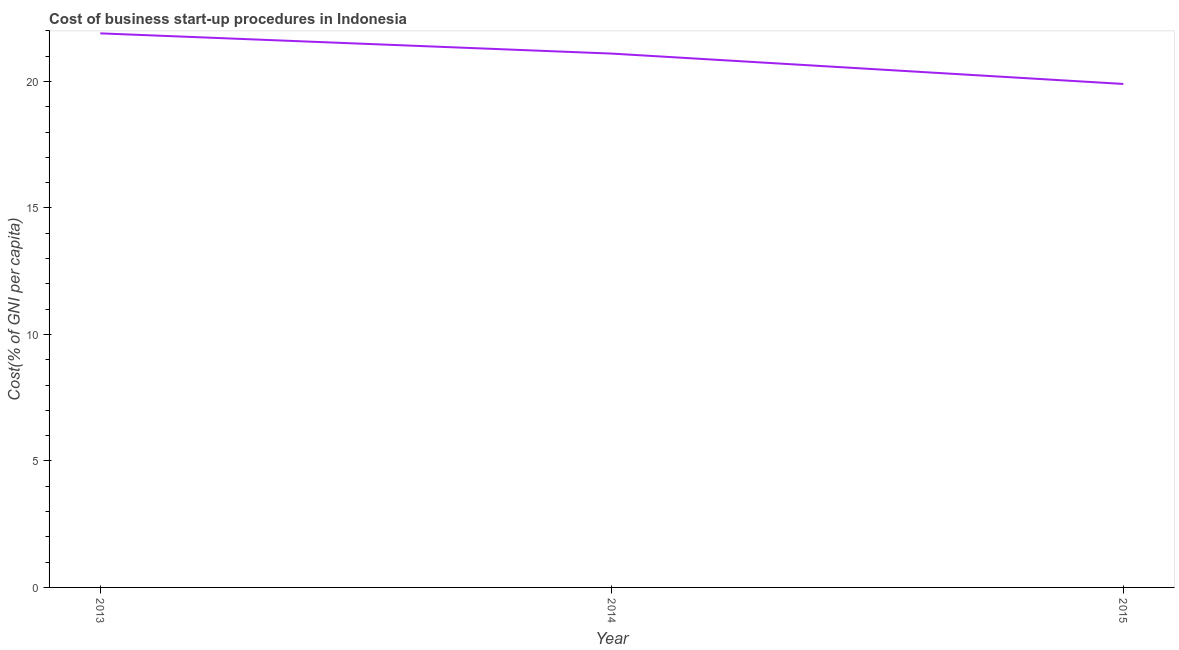What is the cost of business startup procedures in 2014?
Offer a terse response. 21.1. Across all years, what is the maximum cost of business startup procedures?
Provide a short and direct response. 21.9. Across all years, what is the minimum cost of business startup procedures?
Ensure brevity in your answer.  19.9. In which year was the cost of business startup procedures minimum?
Your answer should be very brief. 2015. What is the sum of the cost of business startup procedures?
Your response must be concise. 62.9. What is the average cost of business startup procedures per year?
Your response must be concise. 20.97. What is the median cost of business startup procedures?
Give a very brief answer. 21.1. In how many years, is the cost of business startup procedures greater than 17 %?
Your answer should be very brief. 3. What is the ratio of the cost of business startup procedures in 2013 to that in 2014?
Ensure brevity in your answer.  1.04. Is the cost of business startup procedures in 2013 less than that in 2014?
Offer a very short reply. No. What is the difference between the highest and the second highest cost of business startup procedures?
Your response must be concise. 0.8. Is the sum of the cost of business startup procedures in 2013 and 2015 greater than the maximum cost of business startup procedures across all years?
Your answer should be very brief. Yes. How many lines are there?
Offer a very short reply. 1. How many years are there in the graph?
Your answer should be compact. 3. What is the difference between two consecutive major ticks on the Y-axis?
Ensure brevity in your answer.  5. Does the graph contain grids?
Make the answer very short. No. What is the title of the graph?
Your response must be concise. Cost of business start-up procedures in Indonesia. What is the label or title of the X-axis?
Provide a succinct answer. Year. What is the label or title of the Y-axis?
Provide a succinct answer. Cost(% of GNI per capita). What is the Cost(% of GNI per capita) in 2013?
Provide a succinct answer. 21.9. What is the Cost(% of GNI per capita) in 2014?
Your response must be concise. 21.1. What is the Cost(% of GNI per capita) of 2015?
Make the answer very short. 19.9. What is the difference between the Cost(% of GNI per capita) in 2013 and 2014?
Ensure brevity in your answer.  0.8. What is the difference between the Cost(% of GNI per capita) in 2014 and 2015?
Your response must be concise. 1.2. What is the ratio of the Cost(% of GNI per capita) in 2013 to that in 2014?
Your answer should be very brief. 1.04. What is the ratio of the Cost(% of GNI per capita) in 2013 to that in 2015?
Your answer should be very brief. 1.1. What is the ratio of the Cost(% of GNI per capita) in 2014 to that in 2015?
Provide a short and direct response. 1.06. 